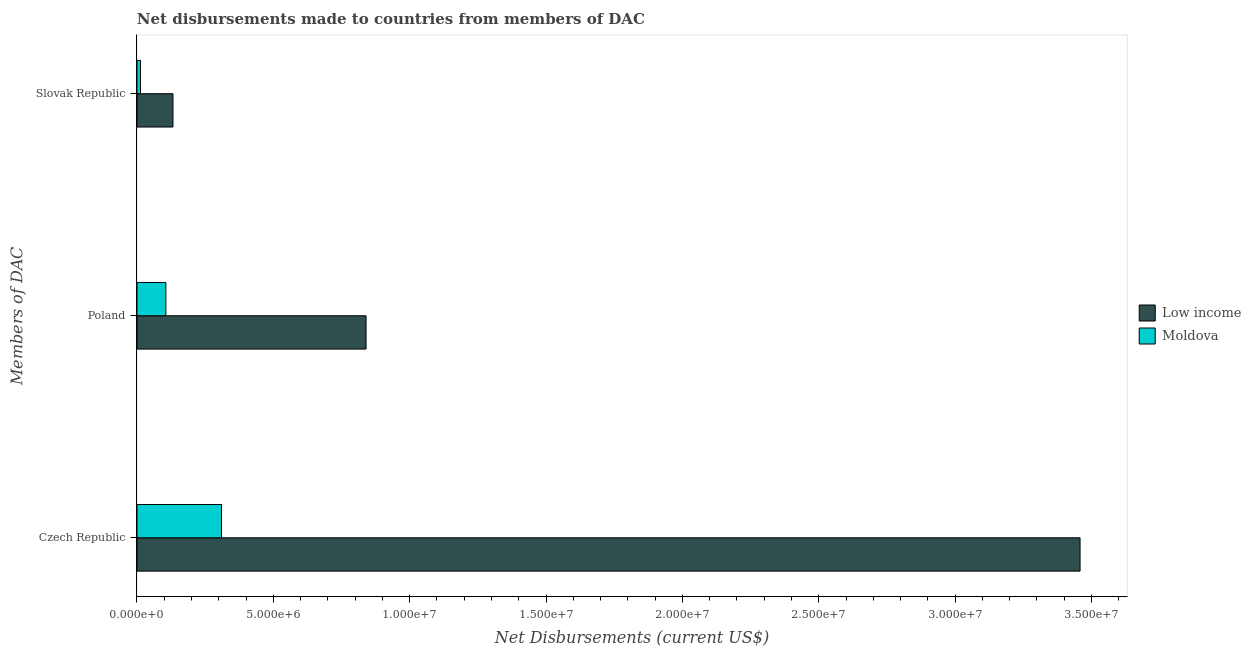How many different coloured bars are there?
Your answer should be compact. 2. Are the number of bars per tick equal to the number of legend labels?
Ensure brevity in your answer.  Yes. Are the number of bars on each tick of the Y-axis equal?
Your answer should be compact. Yes. What is the label of the 1st group of bars from the top?
Provide a succinct answer. Slovak Republic. What is the net disbursements made by poland in Moldova?
Make the answer very short. 1.06e+06. Across all countries, what is the maximum net disbursements made by slovak republic?
Provide a succinct answer. 1.32e+06. Across all countries, what is the minimum net disbursements made by slovak republic?
Your answer should be very brief. 1.30e+05. In which country was the net disbursements made by slovak republic maximum?
Your response must be concise. Low income. In which country was the net disbursements made by poland minimum?
Keep it short and to the point. Moldova. What is the total net disbursements made by poland in the graph?
Ensure brevity in your answer.  9.46e+06. What is the difference between the net disbursements made by poland in Moldova and that in Low income?
Offer a terse response. -7.34e+06. What is the difference between the net disbursements made by poland in Low income and the net disbursements made by slovak republic in Moldova?
Provide a short and direct response. 8.27e+06. What is the average net disbursements made by czech republic per country?
Offer a terse response. 1.88e+07. What is the difference between the net disbursements made by czech republic and net disbursements made by poland in Low income?
Your answer should be compact. 2.62e+07. In how many countries, is the net disbursements made by slovak republic greater than 8000000 US$?
Give a very brief answer. 0. What is the ratio of the net disbursements made by poland in Low income to that in Moldova?
Your answer should be compact. 7.92. Is the difference between the net disbursements made by poland in Moldova and Low income greater than the difference between the net disbursements made by czech republic in Moldova and Low income?
Your answer should be very brief. Yes. What is the difference between the highest and the second highest net disbursements made by poland?
Offer a terse response. 7.34e+06. What is the difference between the highest and the lowest net disbursements made by poland?
Offer a terse response. 7.34e+06. In how many countries, is the net disbursements made by czech republic greater than the average net disbursements made by czech republic taken over all countries?
Offer a very short reply. 1. Is the sum of the net disbursements made by slovak republic in Moldova and Low income greater than the maximum net disbursements made by poland across all countries?
Keep it short and to the point. No. What does the 2nd bar from the top in Poland represents?
Offer a very short reply. Low income. What does the 1st bar from the bottom in Poland represents?
Give a very brief answer. Low income. How many bars are there?
Your answer should be very brief. 6. How many countries are there in the graph?
Offer a terse response. 2. Are the values on the major ticks of X-axis written in scientific E-notation?
Your response must be concise. Yes. Does the graph contain any zero values?
Keep it short and to the point. No. Does the graph contain grids?
Provide a short and direct response. No. How are the legend labels stacked?
Your answer should be compact. Vertical. What is the title of the graph?
Offer a terse response. Net disbursements made to countries from members of DAC. What is the label or title of the X-axis?
Give a very brief answer. Net Disbursements (current US$). What is the label or title of the Y-axis?
Keep it short and to the point. Members of DAC. What is the Net Disbursements (current US$) of Low income in Czech Republic?
Provide a succinct answer. 3.46e+07. What is the Net Disbursements (current US$) in Moldova in Czech Republic?
Give a very brief answer. 3.10e+06. What is the Net Disbursements (current US$) in Low income in Poland?
Give a very brief answer. 8.40e+06. What is the Net Disbursements (current US$) in Moldova in Poland?
Keep it short and to the point. 1.06e+06. What is the Net Disbursements (current US$) in Low income in Slovak Republic?
Give a very brief answer. 1.32e+06. What is the Net Disbursements (current US$) of Moldova in Slovak Republic?
Give a very brief answer. 1.30e+05. Across all Members of DAC, what is the maximum Net Disbursements (current US$) of Low income?
Give a very brief answer. 3.46e+07. Across all Members of DAC, what is the maximum Net Disbursements (current US$) in Moldova?
Keep it short and to the point. 3.10e+06. Across all Members of DAC, what is the minimum Net Disbursements (current US$) of Low income?
Provide a succinct answer. 1.32e+06. Across all Members of DAC, what is the minimum Net Disbursements (current US$) in Moldova?
Give a very brief answer. 1.30e+05. What is the total Net Disbursements (current US$) in Low income in the graph?
Ensure brevity in your answer.  4.43e+07. What is the total Net Disbursements (current US$) in Moldova in the graph?
Your response must be concise. 4.29e+06. What is the difference between the Net Disbursements (current US$) in Low income in Czech Republic and that in Poland?
Ensure brevity in your answer.  2.62e+07. What is the difference between the Net Disbursements (current US$) in Moldova in Czech Republic and that in Poland?
Your response must be concise. 2.04e+06. What is the difference between the Net Disbursements (current US$) in Low income in Czech Republic and that in Slovak Republic?
Give a very brief answer. 3.33e+07. What is the difference between the Net Disbursements (current US$) of Moldova in Czech Republic and that in Slovak Republic?
Offer a terse response. 2.97e+06. What is the difference between the Net Disbursements (current US$) of Low income in Poland and that in Slovak Republic?
Offer a very short reply. 7.08e+06. What is the difference between the Net Disbursements (current US$) of Moldova in Poland and that in Slovak Republic?
Provide a succinct answer. 9.30e+05. What is the difference between the Net Disbursements (current US$) of Low income in Czech Republic and the Net Disbursements (current US$) of Moldova in Poland?
Your answer should be very brief. 3.35e+07. What is the difference between the Net Disbursements (current US$) of Low income in Czech Republic and the Net Disbursements (current US$) of Moldova in Slovak Republic?
Ensure brevity in your answer.  3.44e+07. What is the difference between the Net Disbursements (current US$) of Low income in Poland and the Net Disbursements (current US$) of Moldova in Slovak Republic?
Offer a very short reply. 8.27e+06. What is the average Net Disbursements (current US$) in Low income per Members of DAC?
Your answer should be compact. 1.48e+07. What is the average Net Disbursements (current US$) of Moldova per Members of DAC?
Provide a succinct answer. 1.43e+06. What is the difference between the Net Disbursements (current US$) of Low income and Net Disbursements (current US$) of Moldova in Czech Republic?
Provide a succinct answer. 3.15e+07. What is the difference between the Net Disbursements (current US$) of Low income and Net Disbursements (current US$) of Moldova in Poland?
Your response must be concise. 7.34e+06. What is the difference between the Net Disbursements (current US$) in Low income and Net Disbursements (current US$) in Moldova in Slovak Republic?
Provide a short and direct response. 1.19e+06. What is the ratio of the Net Disbursements (current US$) of Low income in Czech Republic to that in Poland?
Your answer should be very brief. 4.12. What is the ratio of the Net Disbursements (current US$) in Moldova in Czech Republic to that in Poland?
Provide a succinct answer. 2.92. What is the ratio of the Net Disbursements (current US$) in Low income in Czech Republic to that in Slovak Republic?
Your answer should be very brief. 26.2. What is the ratio of the Net Disbursements (current US$) of Moldova in Czech Republic to that in Slovak Republic?
Your answer should be compact. 23.85. What is the ratio of the Net Disbursements (current US$) in Low income in Poland to that in Slovak Republic?
Keep it short and to the point. 6.36. What is the ratio of the Net Disbursements (current US$) of Moldova in Poland to that in Slovak Republic?
Provide a succinct answer. 8.15. What is the difference between the highest and the second highest Net Disbursements (current US$) in Low income?
Give a very brief answer. 2.62e+07. What is the difference between the highest and the second highest Net Disbursements (current US$) of Moldova?
Offer a terse response. 2.04e+06. What is the difference between the highest and the lowest Net Disbursements (current US$) in Low income?
Provide a short and direct response. 3.33e+07. What is the difference between the highest and the lowest Net Disbursements (current US$) of Moldova?
Give a very brief answer. 2.97e+06. 